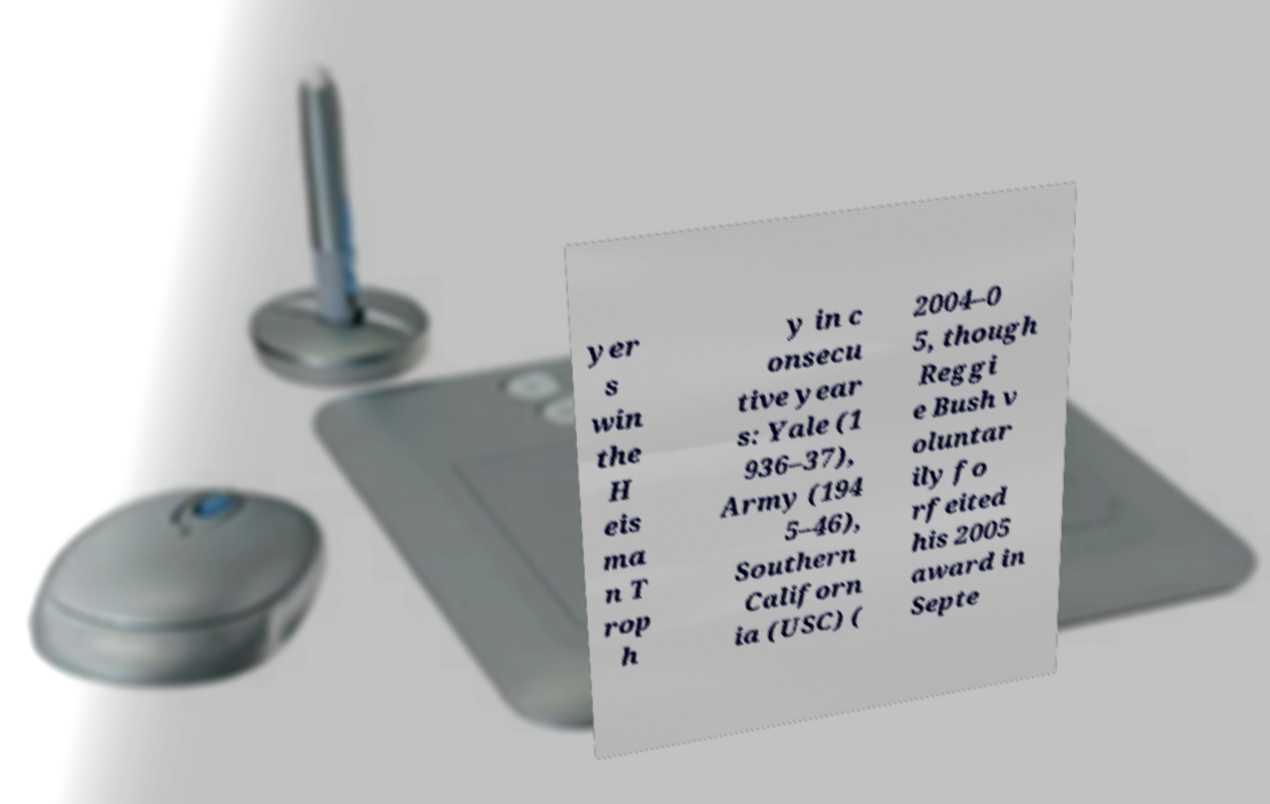Please identify and transcribe the text found in this image. yer s win the H eis ma n T rop h y in c onsecu tive year s: Yale (1 936–37), Army (194 5–46), Southern Californ ia (USC) ( 2004–0 5, though Reggi e Bush v oluntar ily fo rfeited his 2005 award in Septe 